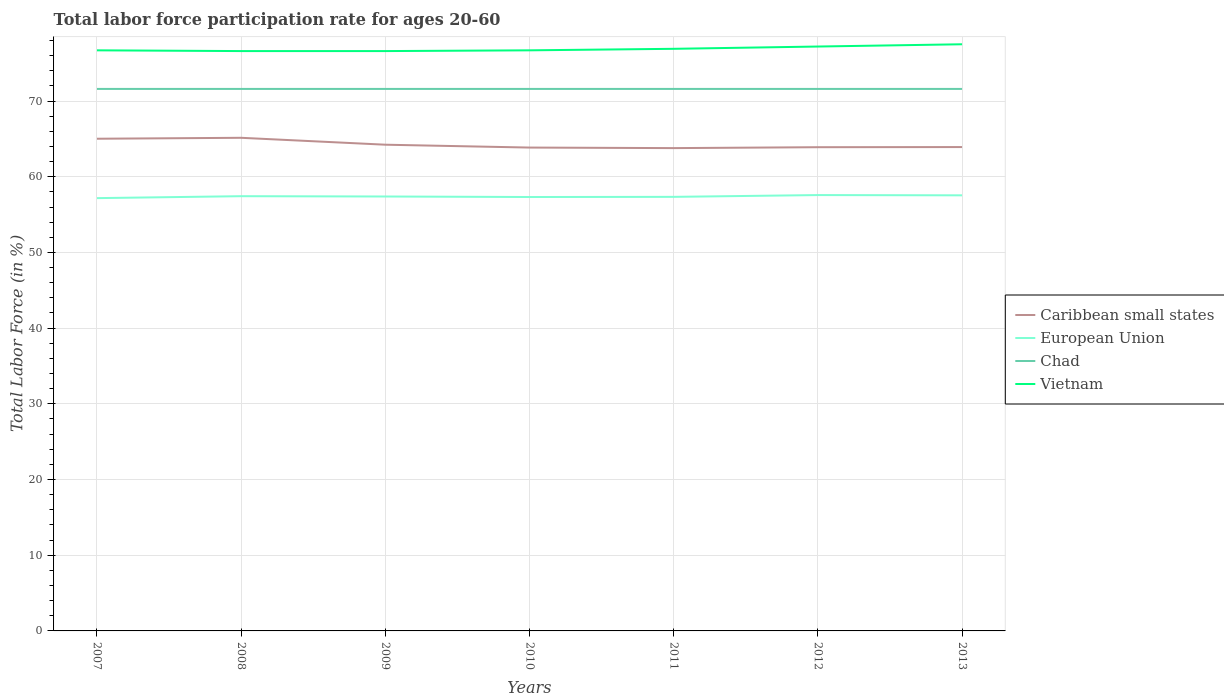How many different coloured lines are there?
Provide a short and direct response. 4. Across all years, what is the maximum labor force participation rate in European Union?
Offer a very short reply. 57.17. In which year was the labor force participation rate in Caribbean small states maximum?
Provide a succinct answer. 2011. What is the total labor force participation rate in Vietnam in the graph?
Offer a very short reply. -0.2. What is the difference between the highest and the second highest labor force participation rate in Chad?
Give a very brief answer. 0. What is the difference between the highest and the lowest labor force participation rate in Caribbean small states?
Ensure brevity in your answer.  2. Is the labor force participation rate in Vietnam strictly greater than the labor force participation rate in European Union over the years?
Your answer should be very brief. No. Are the values on the major ticks of Y-axis written in scientific E-notation?
Keep it short and to the point. No. What is the title of the graph?
Your response must be concise. Total labor force participation rate for ages 20-60. What is the label or title of the X-axis?
Make the answer very short. Years. What is the Total Labor Force (in %) in Caribbean small states in 2007?
Your response must be concise. 65.02. What is the Total Labor Force (in %) in European Union in 2007?
Your answer should be very brief. 57.17. What is the Total Labor Force (in %) of Chad in 2007?
Make the answer very short. 71.6. What is the Total Labor Force (in %) in Vietnam in 2007?
Your response must be concise. 76.7. What is the Total Labor Force (in %) in Caribbean small states in 2008?
Your answer should be compact. 65.14. What is the Total Labor Force (in %) of European Union in 2008?
Provide a succinct answer. 57.43. What is the Total Labor Force (in %) of Chad in 2008?
Your answer should be compact. 71.6. What is the Total Labor Force (in %) of Vietnam in 2008?
Your response must be concise. 76.6. What is the Total Labor Force (in %) in Caribbean small states in 2009?
Offer a very short reply. 64.23. What is the Total Labor Force (in %) of European Union in 2009?
Offer a terse response. 57.39. What is the Total Labor Force (in %) of Chad in 2009?
Offer a terse response. 71.6. What is the Total Labor Force (in %) in Vietnam in 2009?
Provide a succinct answer. 76.6. What is the Total Labor Force (in %) of Caribbean small states in 2010?
Your answer should be very brief. 63.85. What is the Total Labor Force (in %) of European Union in 2010?
Give a very brief answer. 57.32. What is the Total Labor Force (in %) of Chad in 2010?
Offer a very short reply. 71.6. What is the Total Labor Force (in %) of Vietnam in 2010?
Provide a succinct answer. 76.7. What is the Total Labor Force (in %) in Caribbean small states in 2011?
Offer a very short reply. 63.78. What is the Total Labor Force (in %) of European Union in 2011?
Provide a short and direct response. 57.34. What is the Total Labor Force (in %) in Chad in 2011?
Offer a very short reply. 71.6. What is the Total Labor Force (in %) in Vietnam in 2011?
Provide a short and direct response. 76.9. What is the Total Labor Force (in %) in Caribbean small states in 2012?
Give a very brief answer. 63.9. What is the Total Labor Force (in %) of European Union in 2012?
Offer a terse response. 57.58. What is the Total Labor Force (in %) in Chad in 2012?
Your answer should be compact. 71.6. What is the Total Labor Force (in %) of Vietnam in 2012?
Offer a very short reply. 77.2. What is the Total Labor Force (in %) in Caribbean small states in 2013?
Keep it short and to the point. 63.92. What is the Total Labor Force (in %) of European Union in 2013?
Make the answer very short. 57.54. What is the Total Labor Force (in %) of Chad in 2013?
Make the answer very short. 71.6. What is the Total Labor Force (in %) of Vietnam in 2013?
Your response must be concise. 77.5. Across all years, what is the maximum Total Labor Force (in %) of Caribbean small states?
Your response must be concise. 65.14. Across all years, what is the maximum Total Labor Force (in %) in European Union?
Offer a terse response. 57.58. Across all years, what is the maximum Total Labor Force (in %) of Chad?
Keep it short and to the point. 71.6. Across all years, what is the maximum Total Labor Force (in %) in Vietnam?
Make the answer very short. 77.5. Across all years, what is the minimum Total Labor Force (in %) in Caribbean small states?
Give a very brief answer. 63.78. Across all years, what is the minimum Total Labor Force (in %) in European Union?
Provide a succinct answer. 57.17. Across all years, what is the minimum Total Labor Force (in %) in Chad?
Provide a short and direct response. 71.6. Across all years, what is the minimum Total Labor Force (in %) in Vietnam?
Give a very brief answer. 76.6. What is the total Total Labor Force (in %) of Caribbean small states in the graph?
Your response must be concise. 449.85. What is the total Total Labor Force (in %) in European Union in the graph?
Your answer should be compact. 401.78. What is the total Total Labor Force (in %) of Chad in the graph?
Provide a succinct answer. 501.2. What is the total Total Labor Force (in %) of Vietnam in the graph?
Your response must be concise. 538.2. What is the difference between the Total Labor Force (in %) of Caribbean small states in 2007 and that in 2008?
Your response must be concise. -0.12. What is the difference between the Total Labor Force (in %) of European Union in 2007 and that in 2008?
Keep it short and to the point. -0.26. What is the difference between the Total Labor Force (in %) in Caribbean small states in 2007 and that in 2009?
Offer a terse response. 0.79. What is the difference between the Total Labor Force (in %) in European Union in 2007 and that in 2009?
Make the answer very short. -0.21. What is the difference between the Total Labor Force (in %) of Chad in 2007 and that in 2009?
Your response must be concise. 0. What is the difference between the Total Labor Force (in %) in Caribbean small states in 2007 and that in 2010?
Your answer should be very brief. 1.17. What is the difference between the Total Labor Force (in %) in European Union in 2007 and that in 2010?
Keep it short and to the point. -0.15. What is the difference between the Total Labor Force (in %) of Chad in 2007 and that in 2010?
Keep it short and to the point. 0. What is the difference between the Total Labor Force (in %) in Caribbean small states in 2007 and that in 2011?
Provide a succinct answer. 1.24. What is the difference between the Total Labor Force (in %) in European Union in 2007 and that in 2011?
Make the answer very short. -0.17. What is the difference between the Total Labor Force (in %) of Vietnam in 2007 and that in 2011?
Offer a very short reply. -0.2. What is the difference between the Total Labor Force (in %) of Caribbean small states in 2007 and that in 2012?
Offer a very short reply. 1.12. What is the difference between the Total Labor Force (in %) of European Union in 2007 and that in 2012?
Keep it short and to the point. -0.4. What is the difference between the Total Labor Force (in %) in Chad in 2007 and that in 2012?
Offer a very short reply. 0. What is the difference between the Total Labor Force (in %) of Vietnam in 2007 and that in 2012?
Your answer should be compact. -0.5. What is the difference between the Total Labor Force (in %) in Caribbean small states in 2007 and that in 2013?
Keep it short and to the point. 1.1. What is the difference between the Total Labor Force (in %) of European Union in 2007 and that in 2013?
Offer a terse response. -0.37. What is the difference between the Total Labor Force (in %) of Chad in 2007 and that in 2013?
Your answer should be very brief. 0. What is the difference between the Total Labor Force (in %) of Caribbean small states in 2008 and that in 2009?
Ensure brevity in your answer.  0.91. What is the difference between the Total Labor Force (in %) in European Union in 2008 and that in 2009?
Keep it short and to the point. 0.04. What is the difference between the Total Labor Force (in %) in Caribbean small states in 2008 and that in 2010?
Provide a succinct answer. 1.29. What is the difference between the Total Labor Force (in %) of European Union in 2008 and that in 2010?
Ensure brevity in your answer.  0.11. What is the difference between the Total Labor Force (in %) in Caribbean small states in 2008 and that in 2011?
Your answer should be very brief. 1.36. What is the difference between the Total Labor Force (in %) of European Union in 2008 and that in 2011?
Your answer should be very brief. 0.09. What is the difference between the Total Labor Force (in %) of Vietnam in 2008 and that in 2011?
Provide a succinct answer. -0.3. What is the difference between the Total Labor Force (in %) in Caribbean small states in 2008 and that in 2012?
Your answer should be compact. 1.24. What is the difference between the Total Labor Force (in %) of European Union in 2008 and that in 2012?
Keep it short and to the point. -0.15. What is the difference between the Total Labor Force (in %) of Chad in 2008 and that in 2012?
Your answer should be very brief. 0. What is the difference between the Total Labor Force (in %) in Vietnam in 2008 and that in 2012?
Your answer should be compact. -0.6. What is the difference between the Total Labor Force (in %) of Caribbean small states in 2008 and that in 2013?
Make the answer very short. 1.22. What is the difference between the Total Labor Force (in %) in European Union in 2008 and that in 2013?
Offer a very short reply. -0.11. What is the difference between the Total Labor Force (in %) of Chad in 2008 and that in 2013?
Your answer should be compact. 0. What is the difference between the Total Labor Force (in %) in Vietnam in 2008 and that in 2013?
Provide a short and direct response. -0.9. What is the difference between the Total Labor Force (in %) in Caribbean small states in 2009 and that in 2010?
Your response must be concise. 0.38. What is the difference between the Total Labor Force (in %) of European Union in 2009 and that in 2010?
Provide a succinct answer. 0.07. What is the difference between the Total Labor Force (in %) in Caribbean small states in 2009 and that in 2011?
Offer a very short reply. 0.45. What is the difference between the Total Labor Force (in %) in European Union in 2009 and that in 2011?
Your response must be concise. 0.05. What is the difference between the Total Labor Force (in %) of Chad in 2009 and that in 2011?
Give a very brief answer. 0. What is the difference between the Total Labor Force (in %) in Caribbean small states in 2009 and that in 2012?
Provide a short and direct response. 0.33. What is the difference between the Total Labor Force (in %) of European Union in 2009 and that in 2012?
Ensure brevity in your answer.  -0.19. What is the difference between the Total Labor Force (in %) in Caribbean small states in 2009 and that in 2013?
Your answer should be very brief. 0.31. What is the difference between the Total Labor Force (in %) in European Union in 2009 and that in 2013?
Your answer should be very brief. -0.15. What is the difference between the Total Labor Force (in %) in Caribbean small states in 2010 and that in 2011?
Keep it short and to the point. 0.07. What is the difference between the Total Labor Force (in %) in European Union in 2010 and that in 2011?
Offer a very short reply. -0.02. What is the difference between the Total Labor Force (in %) of Caribbean small states in 2010 and that in 2012?
Offer a very short reply. -0.05. What is the difference between the Total Labor Force (in %) of European Union in 2010 and that in 2012?
Ensure brevity in your answer.  -0.26. What is the difference between the Total Labor Force (in %) in Chad in 2010 and that in 2012?
Make the answer very short. 0. What is the difference between the Total Labor Force (in %) in Vietnam in 2010 and that in 2012?
Keep it short and to the point. -0.5. What is the difference between the Total Labor Force (in %) of Caribbean small states in 2010 and that in 2013?
Give a very brief answer. -0.07. What is the difference between the Total Labor Force (in %) of European Union in 2010 and that in 2013?
Provide a succinct answer. -0.22. What is the difference between the Total Labor Force (in %) in Chad in 2010 and that in 2013?
Ensure brevity in your answer.  0. What is the difference between the Total Labor Force (in %) of Vietnam in 2010 and that in 2013?
Provide a short and direct response. -0.8. What is the difference between the Total Labor Force (in %) in Caribbean small states in 2011 and that in 2012?
Offer a very short reply. -0.12. What is the difference between the Total Labor Force (in %) of European Union in 2011 and that in 2012?
Make the answer very short. -0.24. What is the difference between the Total Labor Force (in %) of Chad in 2011 and that in 2012?
Offer a terse response. 0. What is the difference between the Total Labor Force (in %) in Caribbean small states in 2011 and that in 2013?
Your answer should be very brief. -0.14. What is the difference between the Total Labor Force (in %) of European Union in 2011 and that in 2013?
Make the answer very short. -0.2. What is the difference between the Total Labor Force (in %) in Caribbean small states in 2012 and that in 2013?
Your response must be concise. -0.02. What is the difference between the Total Labor Force (in %) in European Union in 2012 and that in 2013?
Your answer should be very brief. 0.04. What is the difference between the Total Labor Force (in %) in Vietnam in 2012 and that in 2013?
Provide a short and direct response. -0.3. What is the difference between the Total Labor Force (in %) of Caribbean small states in 2007 and the Total Labor Force (in %) of European Union in 2008?
Your answer should be very brief. 7.59. What is the difference between the Total Labor Force (in %) in Caribbean small states in 2007 and the Total Labor Force (in %) in Chad in 2008?
Make the answer very short. -6.58. What is the difference between the Total Labor Force (in %) in Caribbean small states in 2007 and the Total Labor Force (in %) in Vietnam in 2008?
Give a very brief answer. -11.58. What is the difference between the Total Labor Force (in %) in European Union in 2007 and the Total Labor Force (in %) in Chad in 2008?
Give a very brief answer. -14.43. What is the difference between the Total Labor Force (in %) of European Union in 2007 and the Total Labor Force (in %) of Vietnam in 2008?
Offer a terse response. -19.43. What is the difference between the Total Labor Force (in %) in Chad in 2007 and the Total Labor Force (in %) in Vietnam in 2008?
Your response must be concise. -5. What is the difference between the Total Labor Force (in %) in Caribbean small states in 2007 and the Total Labor Force (in %) in European Union in 2009?
Give a very brief answer. 7.63. What is the difference between the Total Labor Force (in %) in Caribbean small states in 2007 and the Total Labor Force (in %) in Chad in 2009?
Your answer should be compact. -6.58. What is the difference between the Total Labor Force (in %) in Caribbean small states in 2007 and the Total Labor Force (in %) in Vietnam in 2009?
Your response must be concise. -11.58. What is the difference between the Total Labor Force (in %) of European Union in 2007 and the Total Labor Force (in %) of Chad in 2009?
Provide a short and direct response. -14.43. What is the difference between the Total Labor Force (in %) in European Union in 2007 and the Total Labor Force (in %) in Vietnam in 2009?
Offer a very short reply. -19.43. What is the difference between the Total Labor Force (in %) in Caribbean small states in 2007 and the Total Labor Force (in %) in European Union in 2010?
Provide a succinct answer. 7.7. What is the difference between the Total Labor Force (in %) of Caribbean small states in 2007 and the Total Labor Force (in %) of Chad in 2010?
Keep it short and to the point. -6.58. What is the difference between the Total Labor Force (in %) of Caribbean small states in 2007 and the Total Labor Force (in %) of Vietnam in 2010?
Provide a short and direct response. -11.68. What is the difference between the Total Labor Force (in %) in European Union in 2007 and the Total Labor Force (in %) in Chad in 2010?
Your response must be concise. -14.43. What is the difference between the Total Labor Force (in %) of European Union in 2007 and the Total Labor Force (in %) of Vietnam in 2010?
Your answer should be compact. -19.53. What is the difference between the Total Labor Force (in %) in Chad in 2007 and the Total Labor Force (in %) in Vietnam in 2010?
Keep it short and to the point. -5.1. What is the difference between the Total Labor Force (in %) of Caribbean small states in 2007 and the Total Labor Force (in %) of European Union in 2011?
Ensure brevity in your answer.  7.68. What is the difference between the Total Labor Force (in %) in Caribbean small states in 2007 and the Total Labor Force (in %) in Chad in 2011?
Keep it short and to the point. -6.58. What is the difference between the Total Labor Force (in %) of Caribbean small states in 2007 and the Total Labor Force (in %) of Vietnam in 2011?
Your answer should be compact. -11.88. What is the difference between the Total Labor Force (in %) of European Union in 2007 and the Total Labor Force (in %) of Chad in 2011?
Your answer should be very brief. -14.43. What is the difference between the Total Labor Force (in %) in European Union in 2007 and the Total Labor Force (in %) in Vietnam in 2011?
Provide a short and direct response. -19.73. What is the difference between the Total Labor Force (in %) of Chad in 2007 and the Total Labor Force (in %) of Vietnam in 2011?
Your answer should be very brief. -5.3. What is the difference between the Total Labor Force (in %) in Caribbean small states in 2007 and the Total Labor Force (in %) in European Union in 2012?
Offer a terse response. 7.44. What is the difference between the Total Labor Force (in %) in Caribbean small states in 2007 and the Total Labor Force (in %) in Chad in 2012?
Provide a short and direct response. -6.58. What is the difference between the Total Labor Force (in %) in Caribbean small states in 2007 and the Total Labor Force (in %) in Vietnam in 2012?
Keep it short and to the point. -12.18. What is the difference between the Total Labor Force (in %) of European Union in 2007 and the Total Labor Force (in %) of Chad in 2012?
Your answer should be compact. -14.43. What is the difference between the Total Labor Force (in %) in European Union in 2007 and the Total Labor Force (in %) in Vietnam in 2012?
Your response must be concise. -20.03. What is the difference between the Total Labor Force (in %) of Caribbean small states in 2007 and the Total Labor Force (in %) of European Union in 2013?
Provide a succinct answer. 7.48. What is the difference between the Total Labor Force (in %) of Caribbean small states in 2007 and the Total Labor Force (in %) of Chad in 2013?
Your answer should be compact. -6.58. What is the difference between the Total Labor Force (in %) of Caribbean small states in 2007 and the Total Labor Force (in %) of Vietnam in 2013?
Ensure brevity in your answer.  -12.48. What is the difference between the Total Labor Force (in %) of European Union in 2007 and the Total Labor Force (in %) of Chad in 2013?
Ensure brevity in your answer.  -14.43. What is the difference between the Total Labor Force (in %) of European Union in 2007 and the Total Labor Force (in %) of Vietnam in 2013?
Offer a terse response. -20.33. What is the difference between the Total Labor Force (in %) of Caribbean small states in 2008 and the Total Labor Force (in %) of European Union in 2009?
Provide a short and direct response. 7.75. What is the difference between the Total Labor Force (in %) in Caribbean small states in 2008 and the Total Labor Force (in %) in Chad in 2009?
Give a very brief answer. -6.46. What is the difference between the Total Labor Force (in %) in Caribbean small states in 2008 and the Total Labor Force (in %) in Vietnam in 2009?
Offer a very short reply. -11.46. What is the difference between the Total Labor Force (in %) in European Union in 2008 and the Total Labor Force (in %) in Chad in 2009?
Your answer should be very brief. -14.17. What is the difference between the Total Labor Force (in %) in European Union in 2008 and the Total Labor Force (in %) in Vietnam in 2009?
Keep it short and to the point. -19.17. What is the difference between the Total Labor Force (in %) of Chad in 2008 and the Total Labor Force (in %) of Vietnam in 2009?
Provide a succinct answer. -5. What is the difference between the Total Labor Force (in %) of Caribbean small states in 2008 and the Total Labor Force (in %) of European Union in 2010?
Your answer should be compact. 7.82. What is the difference between the Total Labor Force (in %) of Caribbean small states in 2008 and the Total Labor Force (in %) of Chad in 2010?
Provide a short and direct response. -6.46. What is the difference between the Total Labor Force (in %) of Caribbean small states in 2008 and the Total Labor Force (in %) of Vietnam in 2010?
Offer a terse response. -11.56. What is the difference between the Total Labor Force (in %) in European Union in 2008 and the Total Labor Force (in %) in Chad in 2010?
Offer a terse response. -14.17. What is the difference between the Total Labor Force (in %) in European Union in 2008 and the Total Labor Force (in %) in Vietnam in 2010?
Give a very brief answer. -19.27. What is the difference between the Total Labor Force (in %) of Chad in 2008 and the Total Labor Force (in %) of Vietnam in 2010?
Keep it short and to the point. -5.1. What is the difference between the Total Labor Force (in %) in Caribbean small states in 2008 and the Total Labor Force (in %) in European Union in 2011?
Offer a terse response. 7.8. What is the difference between the Total Labor Force (in %) of Caribbean small states in 2008 and the Total Labor Force (in %) of Chad in 2011?
Make the answer very short. -6.46. What is the difference between the Total Labor Force (in %) in Caribbean small states in 2008 and the Total Labor Force (in %) in Vietnam in 2011?
Give a very brief answer. -11.76. What is the difference between the Total Labor Force (in %) of European Union in 2008 and the Total Labor Force (in %) of Chad in 2011?
Offer a terse response. -14.17. What is the difference between the Total Labor Force (in %) of European Union in 2008 and the Total Labor Force (in %) of Vietnam in 2011?
Give a very brief answer. -19.47. What is the difference between the Total Labor Force (in %) in Caribbean small states in 2008 and the Total Labor Force (in %) in European Union in 2012?
Offer a terse response. 7.57. What is the difference between the Total Labor Force (in %) of Caribbean small states in 2008 and the Total Labor Force (in %) of Chad in 2012?
Make the answer very short. -6.46. What is the difference between the Total Labor Force (in %) in Caribbean small states in 2008 and the Total Labor Force (in %) in Vietnam in 2012?
Your answer should be very brief. -12.06. What is the difference between the Total Labor Force (in %) of European Union in 2008 and the Total Labor Force (in %) of Chad in 2012?
Your answer should be very brief. -14.17. What is the difference between the Total Labor Force (in %) in European Union in 2008 and the Total Labor Force (in %) in Vietnam in 2012?
Offer a very short reply. -19.77. What is the difference between the Total Labor Force (in %) in Caribbean small states in 2008 and the Total Labor Force (in %) in European Union in 2013?
Offer a terse response. 7.6. What is the difference between the Total Labor Force (in %) of Caribbean small states in 2008 and the Total Labor Force (in %) of Chad in 2013?
Keep it short and to the point. -6.46. What is the difference between the Total Labor Force (in %) in Caribbean small states in 2008 and the Total Labor Force (in %) in Vietnam in 2013?
Provide a succinct answer. -12.36. What is the difference between the Total Labor Force (in %) in European Union in 2008 and the Total Labor Force (in %) in Chad in 2013?
Provide a succinct answer. -14.17. What is the difference between the Total Labor Force (in %) in European Union in 2008 and the Total Labor Force (in %) in Vietnam in 2013?
Provide a succinct answer. -20.07. What is the difference between the Total Labor Force (in %) of Chad in 2008 and the Total Labor Force (in %) of Vietnam in 2013?
Make the answer very short. -5.9. What is the difference between the Total Labor Force (in %) in Caribbean small states in 2009 and the Total Labor Force (in %) in European Union in 2010?
Provide a succinct answer. 6.91. What is the difference between the Total Labor Force (in %) of Caribbean small states in 2009 and the Total Labor Force (in %) of Chad in 2010?
Make the answer very short. -7.37. What is the difference between the Total Labor Force (in %) in Caribbean small states in 2009 and the Total Labor Force (in %) in Vietnam in 2010?
Offer a very short reply. -12.47. What is the difference between the Total Labor Force (in %) of European Union in 2009 and the Total Labor Force (in %) of Chad in 2010?
Provide a succinct answer. -14.21. What is the difference between the Total Labor Force (in %) in European Union in 2009 and the Total Labor Force (in %) in Vietnam in 2010?
Offer a terse response. -19.31. What is the difference between the Total Labor Force (in %) of Chad in 2009 and the Total Labor Force (in %) of Vietnam in 2010?
Your answer should be very brief. -5.1. What is the difference between the Total Labor Force (in %) of Caribbean small states in 2009 and the Total Labor Force (in %) of European Union in 2011?
Keep it short and to the point. 6.89. What is the difference between the Total Labor Force (in %) in Caribbean small states in 2009 and the Total Labor Force (in %) in Chad in 2011?
Make the answer very short. -7.37. What is the difference between the Total Labor Force (in %) in Caribbean small states in 2009 and the Total Labor Force (in %) in Vietnam in 2011?
Keep it short and to the point. -12.67. What is the difference between the Total Labor Force (in %) in European Union in 2009 and the Total Labor Force (in %) in Chad in 2011?
Make the answer very short. -14.21. What is the difference between the Total Labor Force (in %) of European Union in 2009 and the Total Labor Force (in %) of Vietnam in 2011?
Keep it short and to the point. -19.51. What is the difference between the Total Labor Force (in %) of Caribbean small states in 2009 and the Total Labor Force (in %) of European Union in 2012?
Provide a short and direct response. 6.65. What is the difference between the Total Labor Force (in %) in Caribbean small states in 2009 and the Total Labor Force (in %) in Chad in 2012?
Your answer should be compact. -7.37. What is the difference between the Total Labor Force (in %) of Caribbean small states in 2009 and the Total Labor Force (in %) of Vietnam in 2012?
Your response must be concise. -12.97. What is the difference between the Total Labor Force (in %) of European Union in 2009 and the Total Labor Force (in %) of Chad in 2012?
Your answer should be very brief. -14.21. What is the difference between the Total Labor Force (in %) of European Union in 2009 and the Total Labor Force (in %) of Vietnam in 2012?
Give a very brief answer. -19.81. What is the difference between the Total Labor Force (in %) of Chad in 2009 and the Total Labor Force (in %) of Vietnam in 2012?
Provide a short and direct response. -5.6. What is the difference between the Total Labor Force (in %) in Caribbean small states in 2009 and the Total Labor Force (in %) in European Union in 2013?
Provide a short and direct response. 6.69. What is the difference between the Total Labor Force (in %) in Caribbean small states in 2009 and the Total Labor Force (in %) in Chad in 2013?
Your response must be concise. -7.37. What is the difference between the Total Labor Force (in %) of Caribbean small states in 2009 and the Total Labor Force (in %) of Vietnam in 2013?
Provide a short and direct response. -13.27. What is the difference between the Total Labor Force (in %) in European Union in 2009 and the Total Labor Force (in %) in Chad in 2013?
Your answer should be compact. -14.21. What is the difference between the Total Labor Force (in %) in European Union in 2009 and the Total Labor Force (in %) in Vietnam in 2013?
Provide a succinct answer. -20.11. What is the difference between the Total Labor Force (in %) of Chad in 2009 and the Total Labor Force (in %) of Vietnam in 2013?
Make the answer very short. -5.9. What is the difference between the Total Labor Force (in %) in Caribbean small states in 2010 and the Total Labor Force (in %) in European Union in 2011?
Offer a terse response. 6.51. What is the difference between the Total Labor Force (in %) in Caribbean small states in 2010 and the Total Labor Force (in %) in Chad in 2011?
Make the answer very short. -7.75. What is the difference between the Total Labor Force (in %) in Caribbean small states in 2010 and the Total Labor Force (in %) in Vietnam in 2011?
Your answer should be compact. -13.05. What is the difference between the Total Labor Force (in %) of European Union in 2010 and the Total Labor Force (in %) of Chad in 2011?
Your answer should be compact. -14.28. What is the difference between the Total Labor Force (in %) in European Union in 2010 and the Total Labor Force (in %) in Vietnam in 2011?
Ensure brevity in your answer.  -19.58. What is the difference between the Total Labor Force (in %) in Caribbean small states in 2010 and the Total Labor Force (in %) in European Union in 2012?
Your response must be concise. 6.27. What is the difference between the Total Labor Force (in %) of Caribbean small states in 2010 and the Total Labor Force (in %) of Chad in 2012?
Provide a short and direct response. -7.75. What is the difference between the Total Labor Force (in %) in Caribbean small states in 2010 and the Total Labor Force (in %) in Vietnam in 2012?
Keep it short and to the point. -13.35. What is the difference between the Total Labor Force (in %) in European Union in 2010 and the Total Labor Force (in %) in Chad in 2012?
Your answer should be very brief. -14.28. What is the difference between the Total Labor Force (in %) of European Union in 2010 and the Total Labor Force (in %) of Vietnam in 2012?
Offer a very short reply. -19.88. What is the difference between the Total Labor Force (in %) of Chad in 2010 and the Total Labor Force (in %) of Vietnam in 2012?
Provide a short and direct response. -5.6. What is the difference between the Total Labor Force (in %) of Caribbean small states in 2010 and the Total Labor Force (in %) of European Union in 2013?
Make the answer very short. 6.31. What is the difference between the Total Labor Force (in %) of Caribbean small states in 2010 and the Total Labor Force (in %) of Chad in 2013?
Offer a very short reply. -7.75. What is the difference between the Total Labor Force (in %) of Caribbean small states in 2010 and the Total Labor Force (in %) of Vietnam in 2013?
Provide a succinct answer. -13.65. What is the difference between the Total Labor Force (in %) in European Union in 2010 and the Total Labor Force (in %) in Chad in 2013?
Your response must be concise. -14.28. What is the difference between the Total Labor Force (in %) of European Union in 2010 and the Total Labor Force (in %) of Vietnam in 2013?
Your answer should be very brief. -20.18. What is the difference between the Total Labor Force (in %) in Caribbean small states in 2011 and the Total Labor Force (in %) in European Union in 2012?
Offer a terse response. 6.2. What is the difference between the Total Labor Force (in %) in Caribbean small states in 2011 and the Total Labor Force (in %) in Chad in 2012?
Your answer should be compact. -7.82. What is the difference between the Total Labor Force (in %) in Caribbean small states in 2011 and the Total Labor Force (in %) in Vietnam in 2012?
Your response must be concise. -13.42. What is the difference between the Total Labor Force (in %) of European Union in 2011 and the Total Labor Force (in %) of Chad in 2012?
Provide a short and direct response. -14.26. What is the difference between the Total Labor Force (in %) in European Union in 2011 and the Total Labor Force (in %) in Vietnam in 2012?
Provide a succinct answer. -19.86. What is the difference between the Total Labor Force (in %) of Caribbean small states in 2011 and the Total Labor Force (in %) of European Union in 2013?
Make the answer very short. 6.24. What is the difference between the Total Labor Force (in %) in Caribbean small states in 2011 and the Total Labor Force (in %) in Chad in 2013?
Keep it short and to the point. -7.82. What is the difference between the Total Labor Force (in %) in Caribbean small states in 2011 and the Total Labor Force (in %) in Vietnam in 2013?
Keep it short and to the point. -13.72. What is the difference between the Total Labor Force (in %) of European Union in 2011 and the Total Labor Force (in %) of Chad in 2013?
Your answer should be very brief. -14.26. What is the difference between the Total Labor Force (in %) of European Union in 2011 and the Total Labor Force (in %) of Vietnam in 2013?
Your answer should be compact. -20.16. What is the difference between the Total Labor Force (in %) in Chad in 2011 and the Total Labor Force (in %) in Vietnam in 2013?
Offer a terse response. -5.9. What is the difference between the Total Labor Force (in %) in Caribbean small states in 2012 and the Total Labor Force (in %) in European Union in 2013?
Keep it short and to the point. 6.36. What is the difference between the Total Labor Force (in %) of Caribbean small states in 2012 and the Total Labor Force (in %) of Chad in 2013?
Your answer should be very brief. -7.7. What is the difference between the Total Labor Force (in %) of Caribbean small states in 2012 and the Total Labor Force (in %) of Vietnam in 2013?
Ensure brevity in your answer.  -13.6. What is the difference between the Total Labor Force (in %) in European Union in 2012 and the Total Labor Force (in %) in Chad in 2013?
Ensure brevity in your answer.  -14.02. What is the difference between the Total Labor Force (in %) in European Union in 2012 and the Total Labor Force (in %) in Vietnam in 2013?
Make the answer very short. -19.92. What is the average Total Labor Force (in %) of Caribbean small states per year?
Offer a terse response. 64.26. What is the average Total Labor Force (in %) of European Union per year?
Offer a terse response. 57.4. What is the average Total Labor Force (in %) of Chad per year?
Offer a terse response. 71.6. What is the average Total Labor Force (in %) in Vietnam per year?
Offer a terse response. 76.89. In the year 2007, what is the difference between the Total Labor Force (in %) in Caribbean small states and Total Labor Force (in %) in European Union?
Your response must be concise. 7.85. In the year 2007, what is the difference between the Total Labor Force (in %) of Caribbean small states and Total Labor Force (in %) of Chad?
Your response must be concise. -6.58. In the year 2007, what is the difference between the Total Labor Force (in %) in Caribbean small states and Total Labor Force (in %) in Vietnam?
Offer a very short reply. -11.68. In the year 2007, what is the difference between the Total Labor Force (in %) of European Union and Total Labor Force (in %) of Chad?
Give a very brief answer. -14.43. In the year 2007, what is the difference between the Total Labor Force (in %) of European Union and Total Labor Force (in %) of Vietnam?
Give a very brief answer. -19.53. In the year 2007, what is the difference between the Total Labor Force (in %) in Chad and Total Labor Force (in %) in Vietnam?
Your answer should be very brief. -5.1. In the year 2008, what is the difference between the Total Labor Force (in %) of Caribbean small states and Total Labor Force (in %) of European Union?
Your response must be concise. 7.71. In the year 2008, what is the difference between the Total Labor Force (in %) in Caribbean small states and Total Labor Force (in %) in Chad?
Provide a succinct answer. -6.46. In the year 2008, what is the difference between the Total Labor Force (in %) of Caribbean small states and Total Labor Force (in %) of Vietnam?
Offer a very short reply. -11.46. In the year 2008, what is the difference between the Total Labor Force (in %) of European Union and Total Labor Force (in %) of Chad?
Give a very brief answer. -14.17. In the year 2008, what is the difference between the Total Labor Force (in %) of European Union and Total Labor Force (in %) of Vietnam?
Ensure brevity in your answer.  -19.17. In the year 2008, what is the difference between the Total Labor Force (in %) of Chad and Total Labor Force (in %) of Vietnam?
Offer a very short reply. -5. In the year 2009, what is the difference between the Total Labor Force (in %) of Caribbean small states and Total Labor Force (in %) of European Union?
Make the answer very short. 6.84. In the year 2009, what is the difference between the Total Labor Force (in %) in Caribbean small states and Total Labor Force (in %) in Chad?
Offer a very short reply. -7.37. In the year 2009, what is the difference between the Total Labor Force (in %) in Caribbean small states and Total Labor Force (in %) in Vietnam?
Offer a very short reply. -12.37. In the year 2009, what is the difference between the Total Labor Force (in %) in European Union and Total Labor Force (in %) in Chad?
Offer a terse response. -14.21. In the year 2009, what is the difference between the Total Labor Force (in %) of European Union and Total Labor Force (in %) of Vietnam?
Your answer should be very brief. -19.21. In the year 2010, what is the difference between the Total Labor Force (in %) of Caribbean small states and Total Labor Force (in %) of European Union?
Provide a short and direct response. 6.53. In the year 2010, what is the difference between the Total Labor Force (in %) of Caribbean small states and Total Labor Force (in %) of Chad?
Your response must be concise. -7.75. In the year 2010, what is the difference between the Total Labor Force (in %) of Caribbean small states and Total Labor Force (in %) of Vietnam?
Offer a terse response. -12.85. In the year 2010, what is the difference between the Total Labor Force (in %) in European Union and Total Labor Force (in %) in Chad?
Offer a terse response. -14.28. In the year 2010, what is the difference between the Total Labor Force (in %) of European Union and Total Labor Force (in %) of Vietnam?
Keep it short and to the point. -19.38. In the year 2011, what is the difference between the Total Labor Force (in %) in Caribbean small states and Total Labor Force (in %) in European Union?
Offer a terse response. 6.44. In the year 2011, what is the difference between the Total Labor Force (in %) in Caribbean small states and Total Labor Force (in %) in Chad?
Provide a succinct answer. -7.82. In the year 2011, what is the difference between the Total Labor Force (in %) of Caribbean small states and Total Labor Force (in %) of Vietnam?
Make the answer very short. -13.12. In the year 2011, what is the difference between the Total Labor Force (in %) of European Union and Total Labor Force (in %) of Chad?
Make the answer very short. -14.26. In the year 2011, what is the difference between the Total Labor Force (in %) of European Union and Total Labor Force (in %) of Vietnam?
Provide a short and direct response. -19.56. In the year 2012, what is the difference between the Total Labor Force (in %) in Caribbean small states and Total Labor Force (in %) in European Union?
Your answer should be very brief. 6.32. In the year 2012, what is the difference between the Total Labor Force (in %) in Caribbean small states and Total Labor Force (in %) in Chad?
Provide a short and direct response. -7.7. In the year 2012, what is the difference between the Total Labor Force (in %) of Caribbean small states and Total Labor Force (in %) of Vietnam?
Provide a short and direct response. -13.3. In the year 2012, what is the difference between the Total Labor Force (in %) of European Union and Total Labor Force (in %) of Chad?
Your response must be concise. -14.02. In the year 2012, what is the difference between the Total Labor Force (in %) of European Union and Total Labor Force (in %) of Vietnam?
Your answer should be very brief. -19.62. In the year 2013, what is the difference between the Total Labor Force (in %) of Caribbean small states and Total Labor Force (in %) of European Union?
Give a very brief answer. 6.38. In the year 2013, what is the difference between the Total Labor Force (in %) in Caribbean small states and Total Labor Force (in %) in Chad?
Make the answer very short. -7.68. In the year 2013, what is the difference between the Total Labor Force (in %) of Caribbean small states and Total Labor Force (in %) of Vietnam?
Give a very brief answer. -13.58. In the year 2013, what is the difference between the Total Labor Force (in %) in European Union and Total Labor Force (in %) in Chad?
Your answer should be compact. -14.06. In the year 2013, what is the difference between the Total Labor Force (in %) in European Union and Total Labor Force (in %) in Vietnam?
Your answer should be compact. -19.96. What is the ratio of the Total Labor Force (in %) of Vietnam in 2007 to that in 2008?
Give a very brief answer. 1. What is the ratio of the Total Labor Force (in %) in Caribbean small states in 2007 to that in 2009?
Keep it short and to the point. 1.01. What is the ratio of the Total Labor Force (in %) in Chad in 2007 to that in 2009?
Make the answer very short. 1. What is the ratio of the Total Labor Force (in %) of Caribbean small states in 2007 to that in 2010?
Your answer should be compact. 1.02. What is the ratio of the Total Labor Force (in %) in European Union in 2007 to that in 2010?
Offer a very short reply. 1. What is the ratio of the Total Labor Force (in %) in Vietnam in 2007 to that in 2010?
Offer a terse response. 1. What is the ratio of the Total Labor Force (in %) of Caribbean small states in 2007 to that in 2011?
Your answer should be very brief. 1.02. What is the ratio of the Total Labor Force (in %) of Chad in 2007 to that in 2011?
Offer a very short reply. 1. What is the ratio of the Total Labor Force (in %) in Vietnam in 2007 to that in 2011?
Provide a short and direct response. 1. What is the ratio of the Total Labor Force (in %) of Caribbean small states in 2007 to that in 2012?
Provide a succinct answer. 1.02. What is the ratio of the Total Labor Force (in %) of Vietnam in 2007 to that in 2012?
Your answer should be compact. 0.99. What is the ratio of the Total Labor Force (in %) in Caribbean small states in 2007 to that in 2013?
Your response must be concise. 1.02. What is the ratio of the Total Labor Force (in %) in Vietnam in 2007 to that in 2013?
Provide a succinct answer. 0.99. What is the ratio of the Total Labor Force (in %) in Caribbean small states in 2008 to that in 2009?
Offer a very short reply. 1.01. What is the ratio of the Total Labor Force (in %) in Chad in 2008 to that in 2009?
Offer a terse response. 1. What is the ratio of the Total Labor Force (in %) in Vietnam in 2008 to that in 2009?
Your answer should be compact. 1. What is the ratio of the Total Labor Force (in %) in Caribbean small states in 2008 to that in 2010?
Give a very brief answer. 1.02. What is the ratio of the Total Labor Force (in %) of European Union in 2008 to that in 2010?
Your response must be concise. 1. What is the ratio of the Total Labor Force (in %) in Chad in 2008 to that in 2010?
Give a very brief answer. 1. What is the ratio of the Total Labor Force (in %) in Vietnam in 2008 to that in 2010?
Ensure brevity in your answer.  1. What is the ratio of the Total Labor Force (in %) of Caribbean small states in 2008 to that in 2011?
Provide a succinct answer. 1.02. What is the ratio of the Total Labor Force (in %) of Chad in 2008 to that in 2011?
Give a very brief answer. 1. What is the ratio of the Total Labor Force (in %) of Caribbean small states in 2008 to that in 2012?
Offer a terse response. 1.02. What is the ratio of the Total Labor Force (in %) in Caribbean small states in 2008 to that in 2013?
Your response must be concise. 1.02. What is the ratio of the Total Labor Force (in %) of European Union in 2008 to that in 2013?
Your answer should be very brief. 1. What is the ratio of the Total Labor Force (in %) of Vietnam in 2008 to that in 2013?
Make the answer very short. 0.99. What is the ratio of the Total Labor Force (in %) in Caribbean small states in 2009 to that in 2010?
Ensure brevity in your answer.  1.01. What is the ratio of the Total Labor Force (in %) in European Union in 2009 to that in 2010?
Provide a short and direct response. 1. What is the ratio of the Total Labor Force (in %) in Vietnam in 2009 to that in 2010?
Offer a very short reply. 1. What is the ratio of the Total Labor Force (in %) of Caribbean small states in 2009 to that in 2011?
Give a very brief answer. 1.01. What is the ratio of the Total Labor Force (in %) in Vietnam in 2009 to that in 2011?
Provide a short and direct response. 1. What is the ratio of the Total Labor Force (in %) of Caribbean small states in 2009 to that in 2012?
Your response must be concise. 1.01. What is the ratio of the Total Labor Force (in %) in Chad in 2009 to that in 2012?
Offer a very short reply. 1. What is the ratio of the Total Labor Force (in %) of Vietnam in 2009 to that in 2012?
Offer a very short reply. 0.99. What is the ratio of the Total Labor Force (in %) in European Union in 2009 to that in 2013?
Give a very brief answer. 1. What is the ratio of the Total Labor Force (in %) in Vietnam in 2009 to that in 2013?
Offer a very short reply. 0.99. What is the ratio of the Total Labor Force (in %) of European Union in 2010 to that in 2011?
Provide a short and direct response. 1. What is the ratio of the Total Labor Force (in %) in Vietnam in 2010 to that in 2011?
Give a very brief answer. 1. What is the ratio of the Total Labor Force (in %) of Caribbean small states in 2010 to that in 2013?
Your answer should be compact. 1. What is the ratio of the Total Labor Force (in %) of European Union in 2010 to that in 2013?
Your answer should be compact. 1. What is the ratio of the Total Labor Force (in %) of Vietnam in 2010 to that in 2013?
Your answer should be compact. 0.99. What is the ratio of the Total Labor Force (in %) of Caribbean small states in 2011 to that in 2012?
Keep it short and to the point. 1. What is the ratio of the Total Labor Force (in %) in European Union in 2011 to that in 2012?
Keep it short and to the point. 1. What is the ratio of the Total Labor Force (in %) of Chad in 2011 to that in 2012?
Your response must be concise. 1. What is the ratio of the Total Labor Force (in %) in Vietnam in 2011 to that in 2012?
Keep it short and to the point. 1. What is the ratio of the Total Labor Force (in %) of Caribbean small states in 2011 to that in 2013?
Offer a terse response. 1. What is the ratio of the Total Labor Force (in %) of European Union in 2011 to that in 2013?
Offer a terse response. 1. What is the ratio of the Total Labor Force (in %) of Chad in 2011 to that in 2013?
Ensure brevity in your answer.  1. What is the difference between the highest and the second highest Total Labor Force (in %) in Caribbean small states?
Your response must be concise. 0.12. What is the difference between the highest and the second highest Total Labor Force (in %) in European Union?
Ensure brevity in your answer.  0.04. What is the difference between the highest and the second highest Total Labor Force (in %) in Chad?
Give a very brief answer. 0. What is the difference between the highest and the lowest Total Labor Force (in %) in Caribbean small states?
Offer a terse response. 1.36. What is the difference between the highest and the lowest Total Labor Force (in %) in European Union?
Your answer should be very brief. 0.4. 